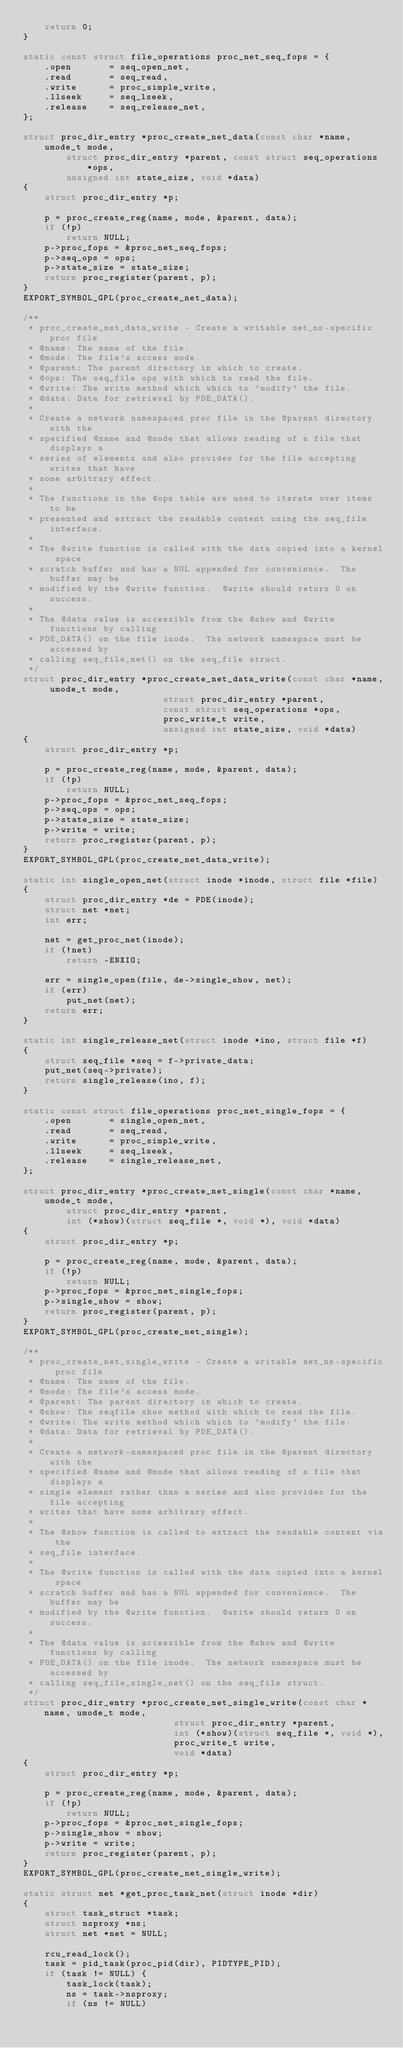<code> <loc_0><loc_0><loc_500><loc_500><_C_>	return 0;
}

static const struct file_operations proc_net_seq_fops = {
	.open		= seq_open_net,
	.read		= seq_read,
	.write		= proc_simple_write,
	.llseek		= seq_lseek,
	.release	= seq_release_net,
};

struct proc_dir_entry *proc_create_net_data(const char *name, umode_t mode,
		struct proc_dir_entry *parent, const struct seq_operations *ops,
		unsigned int state_size, void *data)
{
	struct proc_dir_entry *p;

	p = proc_create_reg(name, mode, &parent, data);
	if (!p)
		return NULL;
	p->proc_fops = &proc_net_seq_fops;
	p->seq_ops = ops;
	p->state_size = state_size;
	return proc_register(parent, p);
}
EXPORT_SYMBOL_GPL(proc_create_net_data);

/**
 * proc_create_net_data_write - Create a writable net_ns-specific proc file
 * @name: The name of the file.
 * @mode: The file's access mode.
 * @parent: The parent directory in which to create.
 * @ops: The seq_file ops with which to read the file.
 * @write: The write method which which to 'modify' the file.
 * @data: Data for retrieval by PDE_DATA().
 *
 * Create a network namespaced proc file in the @parent directory with the
 * specified @name and @mode that allows reading of a file that displays a
 * series of elements and also provides for the file accepting writes that have
 * some arbitrary effect.
 *
 * The functions in the @ops table are used to iterate over items to be
 * presented and extract the readable content using the seq_file interface.
 *
 * The @write function is called with the data copied into a kernel space
 * scratch buffer and has a NUL appended for convenience.  The buffer may be
 * modified by the @write function.  @write should return 0 on success.
 *
 * The @data value is accessible from the @show and @write functions by calling
 * PDE_DATA() on the file inode.  The network namespace must be accessed by
 * calling seq_file_net() on the seq_file struct.
 */
struct proc_dir_entry *proc_create_net_data_write(const char *name, umode_t mode,
						  struct proc_dir_entry *parent,
						  const struct seq_operations *ops,
						  proc_write_t write,
						  unsigned int state_size, void *data)
{
	struct proc_dir_entry *p;

	p = proc_create_reg(name, mode, &parent, data);
	if (!p)
		return NULL;
	p->proc_fops = &proc_net_seq_fops;
	p->seq_ops = ops;
	p->state_size = state_size;
	p->write = write;
	return proc_register(parent, p);
}
EXPORT_SYMBOL_GPL(proc_create_net_data_write);

static int single_open_net(struct inode *inode, struct file *file)
{
	struct proc_dir_entry *de = PDE(inode);
	struct net *net;
	int err;

	net = get_proc_net(inode);
	if (!net)
		return -ENXIO;

	err = single_open(file, de->single_show, net);
	if (err)
		put_net(net);
	return err;
}

static int single_release_net(struct inode *ino, struct file *f)
{
	struct seq_file *seq = f->private_data;
	put_net(seq->private);
	return single_release(ino, f);
}

static const struct file_operations proc_net_single_fops = {
	.open		= single_open_net,
	.read		= seq_read,
	.write		= proc_simple_write,
	.llseek		= seq_lseek,
	.release	= single_release_net,
};

struct proc_dir_entry *proc_create_net_single(const char *name, umode_t mode,
		struct proc_dir_entry *parent,
		int (*show)(struct seq_file *, void *), void *data)
{
	struct proc_dir_entry *p;

	p = proc_create_reg(name, mode, &parent, data);
	if (!p)
		return NULL;
	p->proc_fops = &proc_net_single_fops;
	p->single_show = show;
	return proc_register(parent, p);
}
EXPORT_SYMBOL_GPL(proc_create_net_single);

/**
 * proc_create_net_single_write - Create a writable net_ns-specific proc file
 * @name: The name of the file.
 * @mode: The file's access mode.
 * @parent: The parent directory in which to create.
 * @show: The seqfile show method with which to read the file.
 * @write: The write method which which to 'modify' the file.
 * @data: Data for retrieval by PDE_DATA().
 *
 * Create a network-namespaced proc file in the @parent directory with the
 * specified @name and @mode that allows reading of a file that displays a
 * single element rather than a series and also provides for the file accepting
 * writes that have some arbitrary effect.
 *
 * The @show function is called to extract the readable content via the
 * seq_file interface.
 *
 * The @write function is called with the data copied into a kernel space
 * scratch buffer and has a NUL appended for convenience.  The buffer may be
 * modified by the @write function.  @write should return 0 on success.
 *
 * The @data value is accessible from the @show and @write functions by calling
 * PDE_DATA() on the file inode.  The network namespace must be accessed by
 * calling seq_file_single_net() on the seq_file struct.
 */
struct proc_dir_entry *proc_create_net_single_write(const char *name, umode_t mode,
						    struct proc_dir_entry *parent,
						    int (*show)(struct seq_file *, void *),
						    proc_write_t write,
						    void *data)
{
	struct proc_dir_entry *p;

	p = proc_create_reg(name, mode, &parent, data);
	if (!p)
		return NULL;
	p->proc_fops = &proc_net_single_fops;
	p->single_show = show;
	p->write = write;
	return proc_register(parent, p);
}
EXPORT_SYMBOL_GPL(proc_create_net_single_write);

static struct net *get_proc_task_net(struct inode *dir)
{
	struct task_struct *task;
	struct nsproxy *ns;
	struct net *net = NULL;

	rcu_read_lock();
	task = pid_task(proc_pid(dir), PIDTYPE_PID);
	if (task != NULL) {
		task_lock(task);
		ns = task->nsproxy;
		if (ns != NULL)</code> 